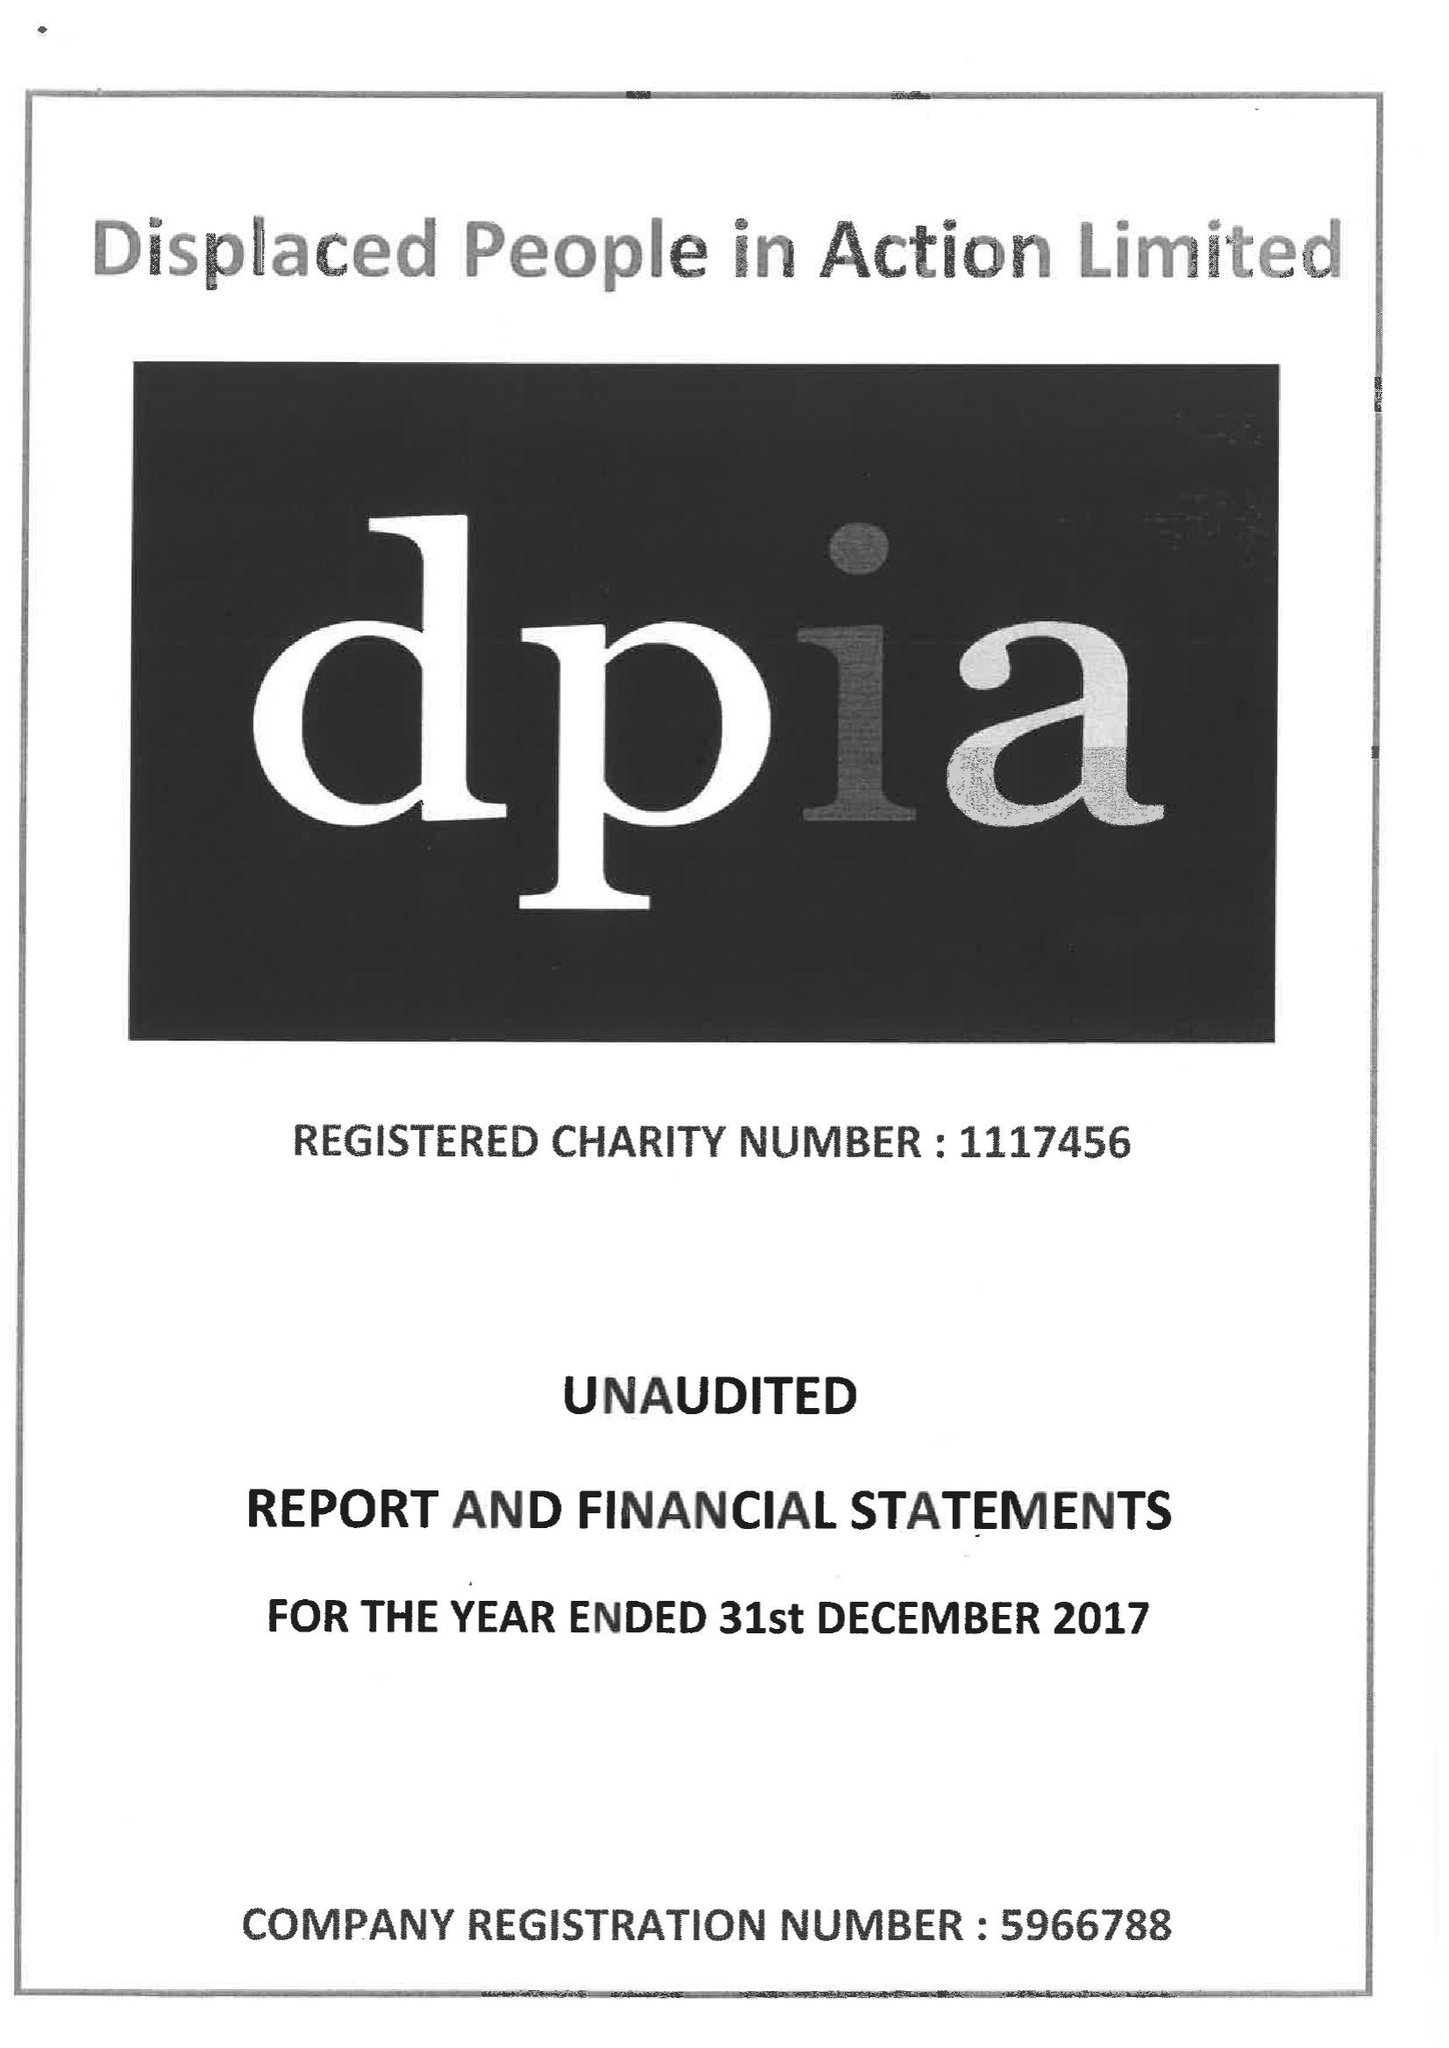What is the value for the charity_name?
Answer the question using a single word or phrase. Displaced People In Action Ltd. 